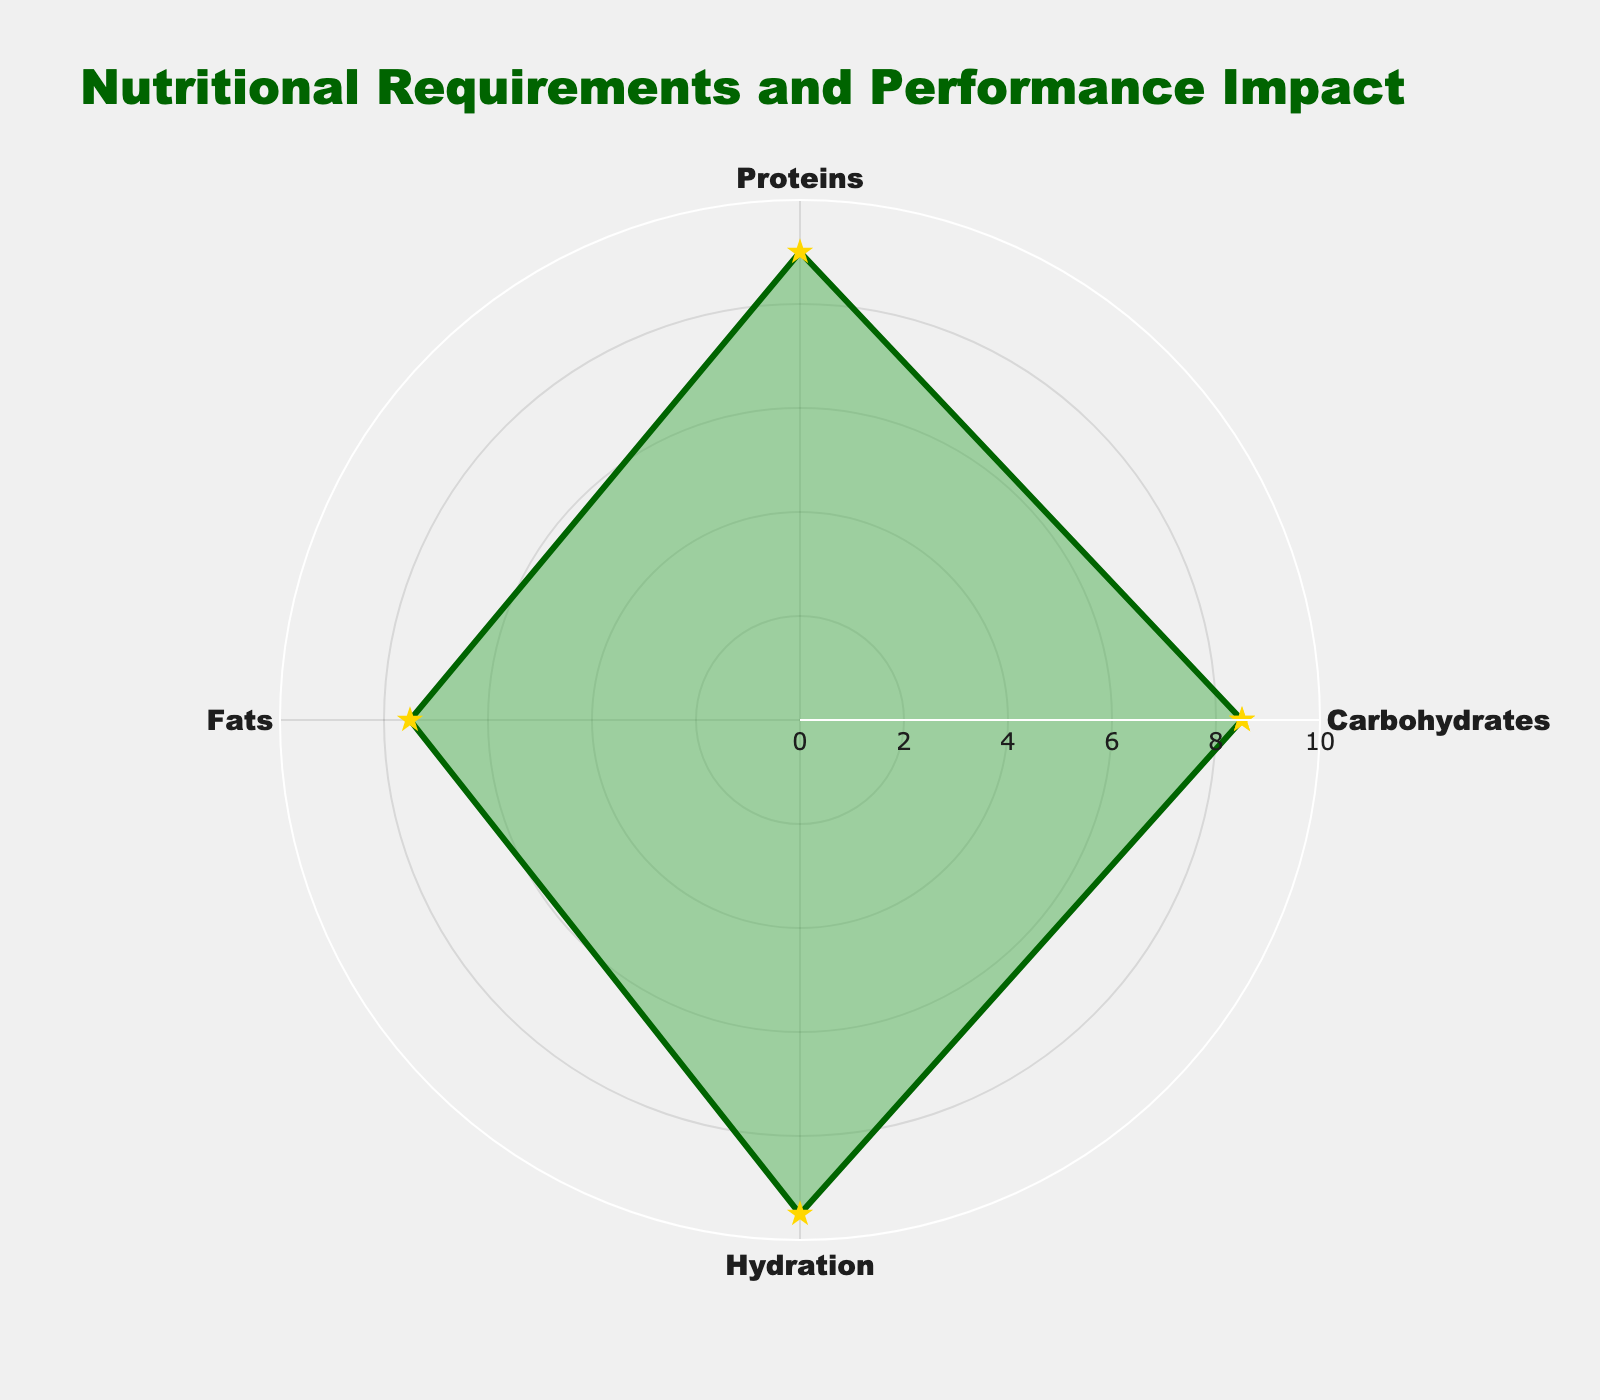What is the title of the radar chart? The title is displayed prominently at the top of the chart, which shows that we are visualizing nutritional requirements and their impact on performance.
Answer: Nutritional Requirements and Performance Impact Which nutrient has the highest Performance Impact Score? By examining the outermost points on the radar chart, we identify that Hydration extends the furthest, indicating it has the highest score.
Answer: Hydration How does the Performance Impact Score of Fats compare to Carbohydrates? By looking at the relative positions of Fats and Carbohydrates on the radar chart, Carbohydrates are farther from the origin compared to Fats in the Performance Impact dimension.
Answer: Carbohydrates have a higher score What is the average Performance Impact Score of all the nutrients? The scores are 8.5, 9.0, 7.5, and 9.5. Summing these values gives 34.5, and dividing by the number of nutrients (4), we get 8.625.
Answer: 8.625 Which nutrient has the smallest Performance Impact Score and what is it? By identifying the innermost point on the radar chart, we determine that Fats have the smallest score. The corresponding value is 7.5.
Answer: Fats, 7.5 Order the nutrients from highest to lowest Performance Impact Score. Starting from the outermost points and moving inwards, the sequence is Hydration, Proteins, Carbohydrates, and Fats.
Answer: Hydration, Proteins, Carbohydrates, Fats What can you infer about the hydration requirements based on the radar chart data? The hydration component has the highest Performance Impact Score, indicating it plays a crucial role in performance, likely suggesting that maintaining proper hydration is critical for optimal performance.
Answer: It is crucial for performance How many distinct nutrients are being evaluated in the radar chart? By counting the different categories listed around the radar chart perimeter, we identify that there are four distinct nutrients being assessed.
Answer: Four What is the combined Performance Impact Score of Carbohydrates and Proteins? The individual scores for Carbohydrates and Proteins are 8.5 and 9.0, respectively. Adding these together gives a total score of 17.5.
Answer: 17.5 